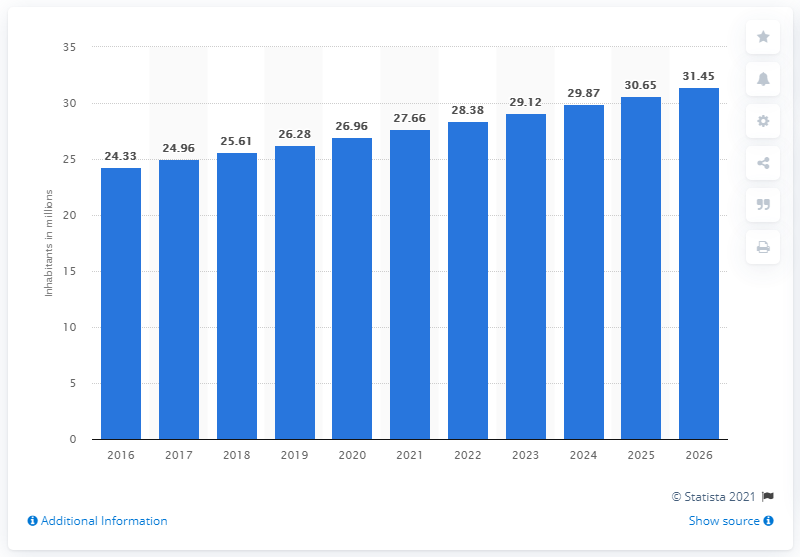Outline some significant characteristics in this image. The population projection for the Ivory Coast is expected to be in 2026. In 2019, the population of the Ivory Coast was approximately 26.96 million people. 